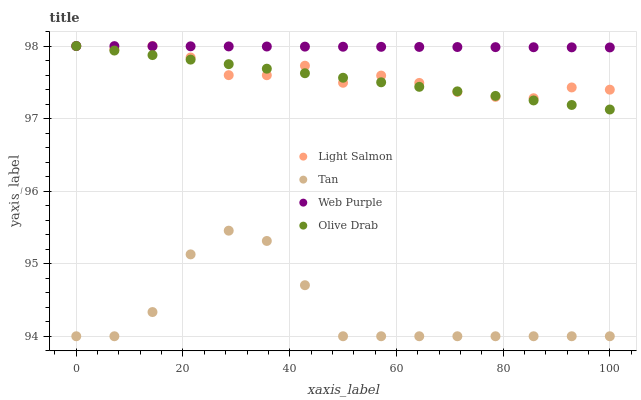Does Tan have the minimum area under the curve?
Answer yes or no. Yes. Does Web Purple have the maximum area under the curve?
Answer yes or no. Yes. Does Light Salmon have the minimum area under the curve?
Answer yes or no. No. Does Light Salmon have the maximum area under the curve?
Answer yes or no. No. Is Web Purple the smoothest?
Answer yes or no. Yes. Is Tan the roughest?
Answer yes or no. Yes. Is Light Salmon the smoothest?
Answer yes or no. No. Is Light Salmon the roughest?
Answer yes or no. No. Does Tan have the lowest value?
Answer yes or no. Yes. Does Light Salmon have the lowest value?
Answer yes or no. No. Does Olive Drab have the highest value?
Answer yes or no. Yes. Does Tan have the highest value?
Answer yes or no. No. Is Tan less than Olive Drab?
Answer yes or no. Yes. Is Olive Drab greater than Tan?
Answer yes or no. Yes. Does Olive Drab intersect Web Purple?
Answer yes or no. Yes. Is Olive Drab less than Web Purple?
Answer yes or no. No. Is Olive Drab greater than Web Purple?
Answer yes or no. No. Does Tan intersect Olive Drab?
Answer yes or no. No. 